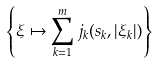Convert formula to latex. <formula><loc_0><loc_0><loc_500><loc_500>\left \{ \xi \mapsto \sum _ { k = 1 } ^ { m } j _ { k } ( s _ { k } , | \xi _ { k } | ) \right \}</formula> 